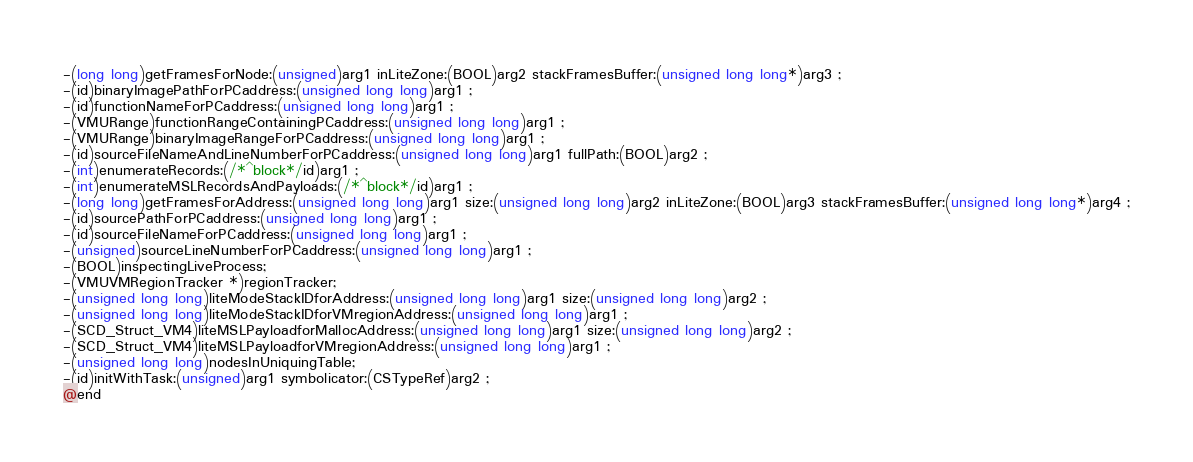Convert code to text. <code><loc_0><loc_0><loc_500><loc_500><_C_>-(long long)getFramesForNode:(unsigned)arg1 inLiteZone:(BOOL)arg2 stackFramesBuffer:(unsigned long long*)arg3 ;
-(id)binaryImagePathForPCaddress:(unsigned long long)arg1 ;
-(id)functionNameForPCaddress:(unsigned long long)arg1 ;
-(VMURange)functionRangeContainingPCaddress:(unsigned long long)arg1 ;
-(VMURange)binaryImageRangeForPCaddress:(unsigned long long)arg1 ;
-(id)sourceFileNameAndLineNumberForPCaddress:(unsigned long long)arg1 fullPath:(BOOL)arg2 ;
-(int)enumerateRecords:(/*^block*/id)arg1 ;
-(int)enumerateMSLRecordsAndPayloads:(/*^block*/id)arg1 ;
-(long long)getFramesForAddress:(unsigned long long)arg1 size:(unsigned long long)arg2 inLiteZone:(BOOL)arg3 stackFramesBuffer:(unsigned long long*)arg4 ;
-(id)sourcePathForPCaddress:(unsigned long long)arg1 ;
-(id)sourceFileNameForPCaddress:(unsigned long long)arg1 ;
-(unsigned)sourceLineNumberForPCaddress:(unsigned long long)arg1 ;
-(BOOL)inspectingLiveProcess;
-(VMUVMRegionTracker *)regionTracker;
-(unsigned long long)liteModeStackIDforAddress:(unsigned long long)arg1 size:(unsigned long long)arg2 ;
-(unsigned long long)liteModeStackIDforVMregionAddress:(unsigned long long)arg1 ;
-(SCD_Struct_VM4)liteMSLPayloadforMallocAddress:(unsigned long long)arg1 size:(unsigned long long)arg2 ;
-(SCD_Struct_VM4)liteMSLPayloadforVMregionAddress:(unsigned long long)arg1 ;
-(unsigned long long)nodesInUniquingTable;
-(id)initWithTask:(unsigned)arg1 symbolicator:(CSTypeRef)arg2 ;
@end

</code> 